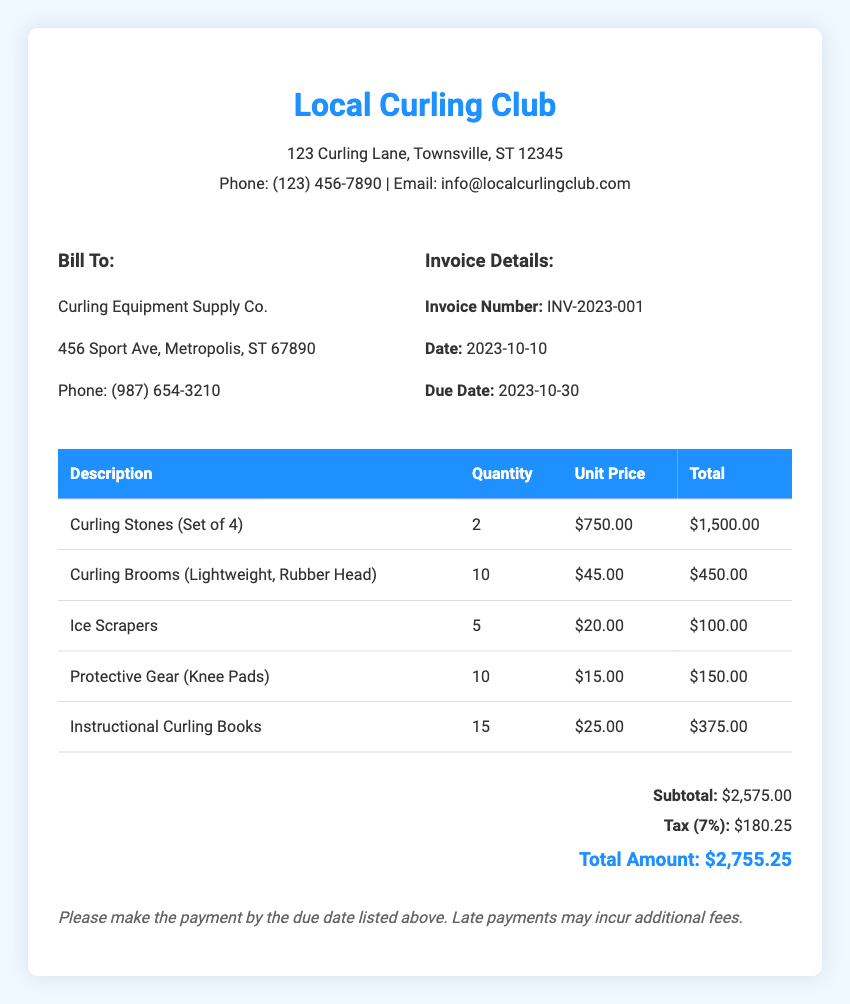What is the invoice number? The invoice number is a unique identifier for the bill, found in the invoice details section.
Answer: INV-2023-001 What is the total amount due? The total amount due is found at the bottom of the invoice and includes subtotal and tax.
Answer: $2,755.25 How many curling stones were purchased? The quantity of curling stones purchased is listed in the itemized table of the invoice.
Answer: 2 What is the unit price of a curling broom? The unit price for curling brooms can be found in the itemized costs table.
Answer: $45.00 What is the due date for the invoice payment? The due date for payment is specified in the invoice details section.
Answer: 2023-10-30 What is the subtotal before tax? The subtotal is the total of all items before any taxes are added, located in the total section of the invoice.
Answer: $2,575.00 How many instructional curling books were ordered? The number of instructional curling books is itemized in the bill, showing how many were ordered.
Answer: 15 What is the tax rate applied to the invoice? The tax rate is mentioned alongside the tax amount in the total section.
Answer: 7% What is the total cost for ice scrapers? The total cost for ice scrapers is the product of the quantity and unit price, found in the itemized costs section.
Answer: $100.00 